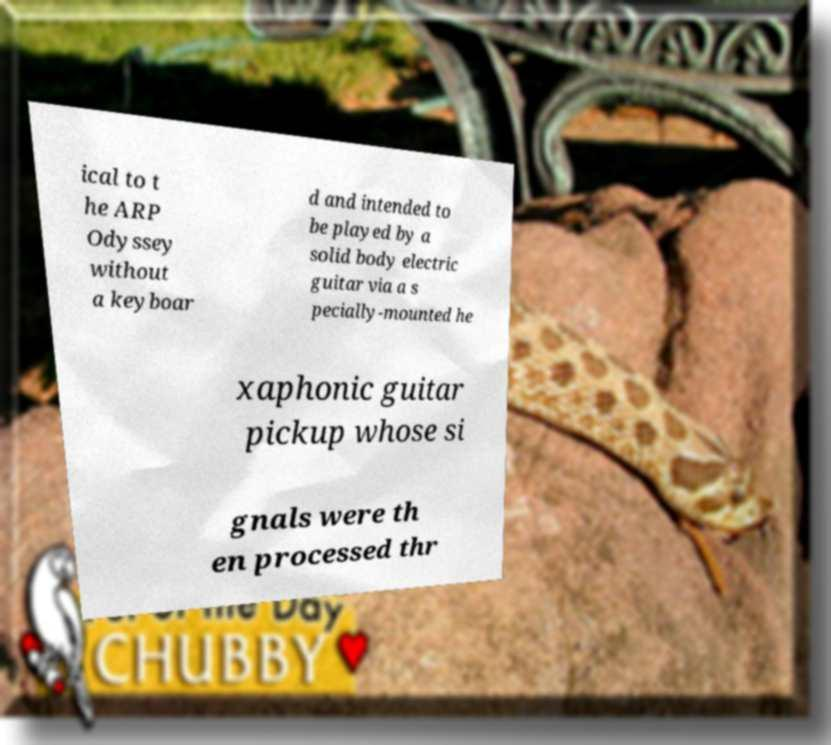There's text embedded in this image that I need extracted. Can you transcribe it verbatim? ical to t he ARP Odyssey without a keyboar d and intended to be played by a solid body electric guitar via a s pecially-mounted he xaphonic guitar pickup whose si gnals were th en processed thr 